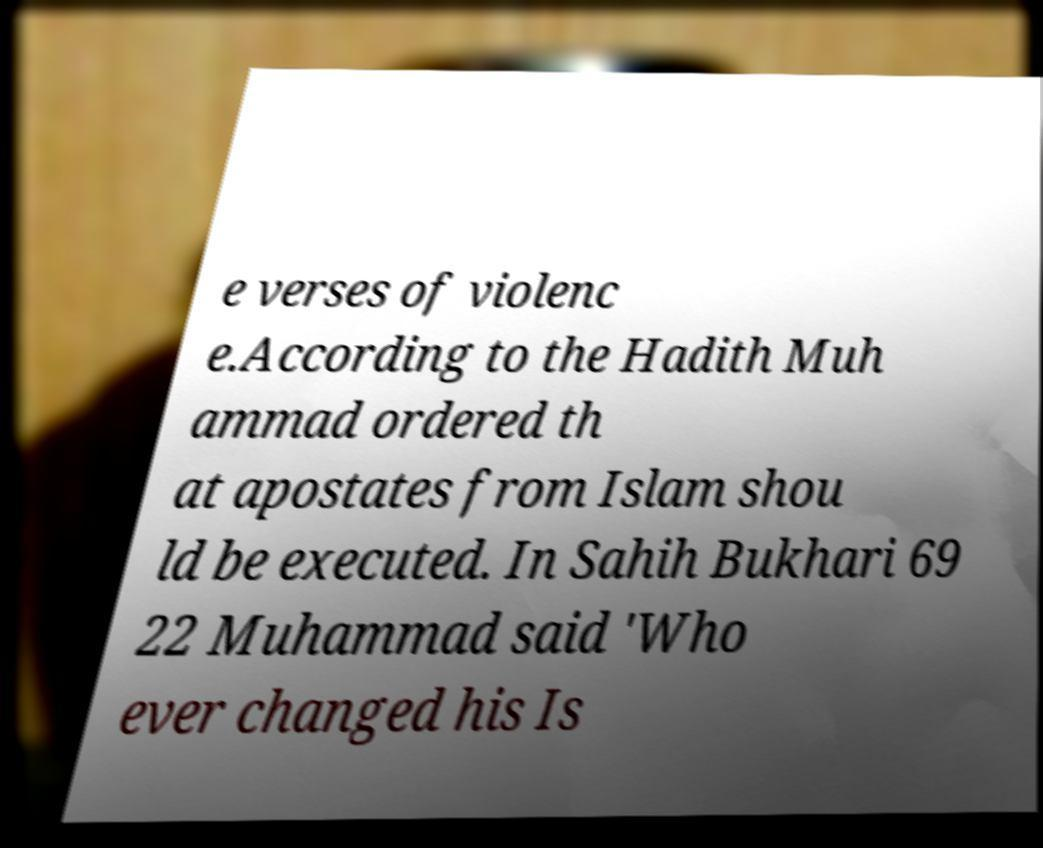Please read and relay the text visible in this image. What does it say? e verses of violenc e.According to the Hadith Muh ammad ordered th at apostates from Islam shou ld be executed. In Sahih Bukhari 69 22 Muhammad said 'Who ever changed his Is 